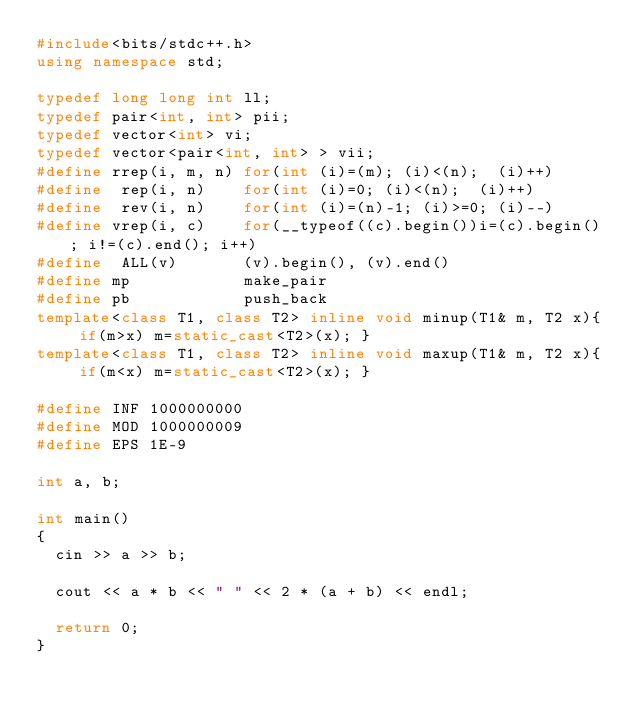<code> <loc_0><loc_0><loc_500><loc_500><_C++_>#include<bits/stdc++.h>
using namespace std;

typedef long long int ll;
typedef pair<int, int> pii;
typedef vector<int> vi;
typedef vector<pair<int, int> > vii;
#define rrep(i, m, n) for(int (i)=(m); (i)<(n);  (i)++)
#define  rep(i, n)    for(int (i)=0; (i)<(n);  (i)++)
#define  rev(i, n)    for(int (i)=(n)-1; (i)>=0; (i)--)
#define vrep(i, c)    for(__typeof((c).begin())i=(c).begin(); i!=(c).end(); i++)
#define  ALL(v)       (v).begin(), (v).end()
#define mp            make_pair
#define pb            push_back
template<class T1, class T2> inline void minup(T1& m, T2 x){ if(m>x) m=static_cast<T2>(x); }
template<class T1, class T2> inline void maxup(T1& m, T2 x){ if(m<x) m=static_cast<T2>(x); }

#define INF 1000000000
#define MOD 1000000009
#define EPS 1E-9

int a, b;

int main()
{
  cin >> a >> b;

  cout << a * b << " " << 2 * (a + b) << endl;

  return 0;
}</code> 